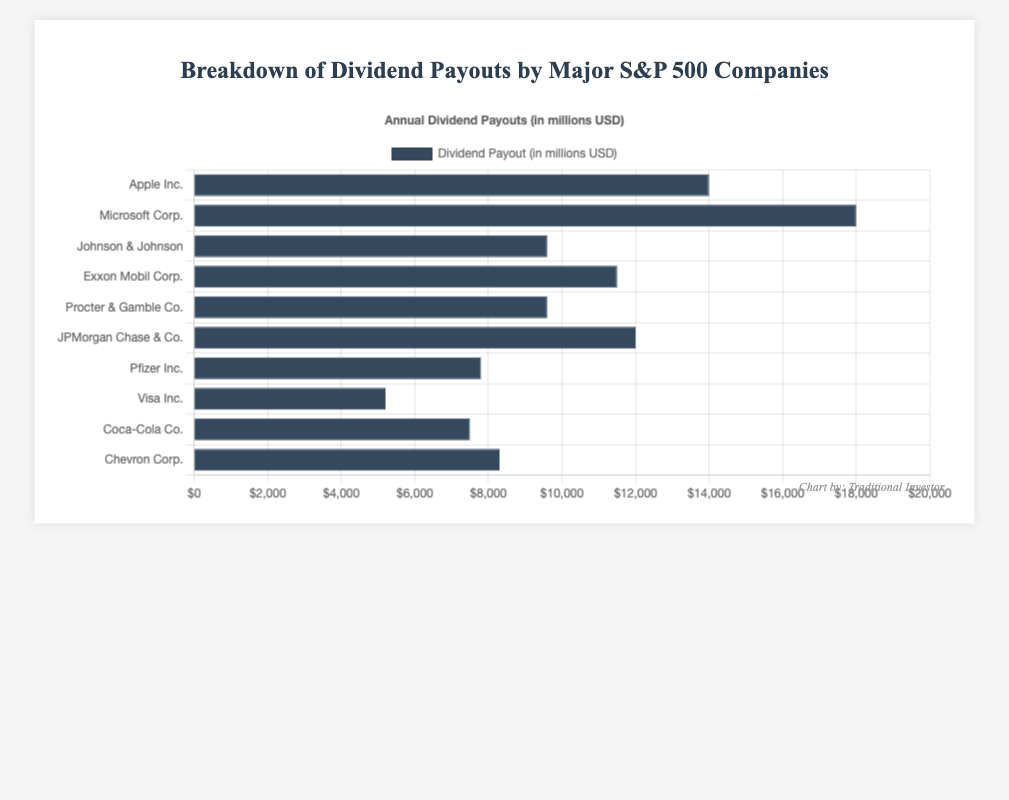Which company has the highest dividend payout? By examining the lengths of the bars, Microsoft Corp. has the longest bar, indicating the highest payout at $18,000.75 million.
Answer: Microsoft Corp Which two companies have the smallest difference in their dividend payouts? Johnson & Johnson and Procter & Gamble Co. have very close dividend payouts; Johnson & Johnson at $9,600.50 million and Procter & Gamble Co. at $9,600.00 million, resulting in a difference of $0.50 million.
Answer: Johnson & Johnson and Procter & Gamble Co What is the total dividend payout by Apple Inc. and Microsoft Corp. combined? Apple Inc. has a payout of $14,000.05 million, and Microsoft Corp. has $18,000.75 million. Summing these amounts: $14,000.05 + $18,000.75 = $32,000.80 million.
Answer: $32,000.80 million How much more is JPMorgan Chase & Co.'s dividend payout compared to Coca-Cola Co.? JPMorgan Chase & Co. has a payout of $12,000.85 million, and Coca-Cola Co. has $7,500.10 million. The difference: $12,000.85 - $7,500.10 = $4,500.75 million.
Answer: $4,500.75 million Which company has a payout closest to $10,000 million? Johnson & Johnson at $9,600.50 million and Procter & Gamble Co. at $9,600.00 million are the closest, both approximately close to $10,000 million.
Answer: Johnson & Johnson and Procter & Gamble Co What is the combined dividend payout of all companies listed? Summing all the dividend payouts: $14,000.05 (Apple Inc.) + $18,000.75 (Microsoft Corp.) + $9,600.50 (Johnson & Johnson) + $11,500.25 (Exxon Mobil Corp.) + $9,600.00 (Procter & Gamble Co.) + $12,000.85 (JPMorgan Chase & Co.) + $7,800.90 (Pfizer Inc.) + $5,200.45 (Visa Inc.) + $7,500.10 (Coca-Cola Co.) + $8,300.65 (Chevron Corp.), totaling approximately $103,503.50 million.
Answer: $103,503.50 million Which companies have a dividend payout greater than $10,000 million but less than $15,000 million? Based on the visual lengths of the bars and the exact values: Apple Inc. ($14,000.05 million), JPMorgan Chase & Co. ($12,000.85 million), and Exxon Mobil Corp. ($11,500.25 million) fall within this range.
Answer: Apple Inc., JPMorgan Chase & Co., and Exxon Mobil Corp 